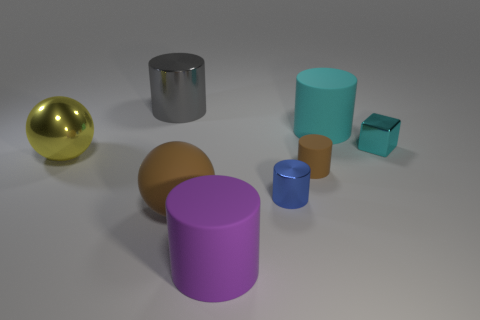What size is the shiny thing that is on the right side of the large brown matte ball and behind the blue shiny object?
Keep it short and to the point. Small. There is a brown rubber object that is on the right side of the small metallic thing that is left of the big matte cylinder that is behind the rubber ball; what is its size?
Provide a short and direct response. Small. What is the size of the cyan matte cylinder?
Your answer should be compact. Large. Is there a small cyan metal cube on the right side of the large matte cylinder that is in front of the sphere that is on the right side of the yellow metallic object?
Your answer should be very brief. Yes. How many small things are cyan rubber cylinders or gray metal cubes?
Make the answer very short. 0. Is there anything else of the same color as the block?
Your answer should be compact. Yes. Do the metallic thing on the left side of the gray shiny cylinder and the purple matte cylinder have the same size?
Offer a terse response. Yes. The small shiny thing to the right of the large matte cylinder that is behind the big metal thing in front of the metallic block is what color?
Your response must be concise. Cyan. The shiny block has what color?
Your answer should be very brief. Cyan. Is the color of the large matte sphere the same as the small rubber object?
Keep it short and to the point. Yes. 